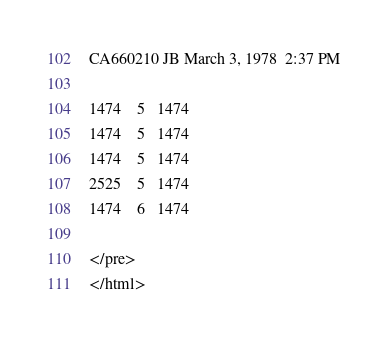<code> <loc_0><loc_0><loc_500><loc_500><_HTML_>CA660210 JB March 3, 1978  2:37 PM

1474	5	1474
1474	5	1474
1474	5	1474
2525	5	1474
1474	6	1474

</pre>
</html>
</code> 